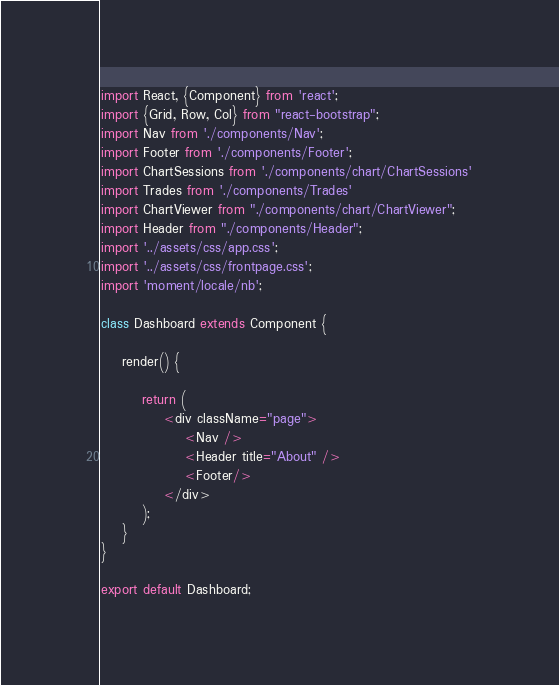<code> <loc_0><loc_0><loc_500><loc_500><_JavaScript_>import React, {Component} from 'react';
import {Grid, Row, Col} from "react-bootstrap";
import Nav from './components/Nav';
import Footer from './components/Footer';
import ChartSessions from './components/chart/ChartSessions'
import Trades from './components/Trades'
import ChartViewer from "./components/chart/ChartViewer";
import Header from "./components/Header";
import '../assets/css/app.css';
import '../assets/css/frontpage.css';
import 'moment/locale/nb';

class Dashboard extends Component {

    render() {

        return (
            <div className="page">
                <Nav />
                <Header title="About" />
                <Footer/>
            </div>
        );
    }
}

export default Dashboard;
</code> 